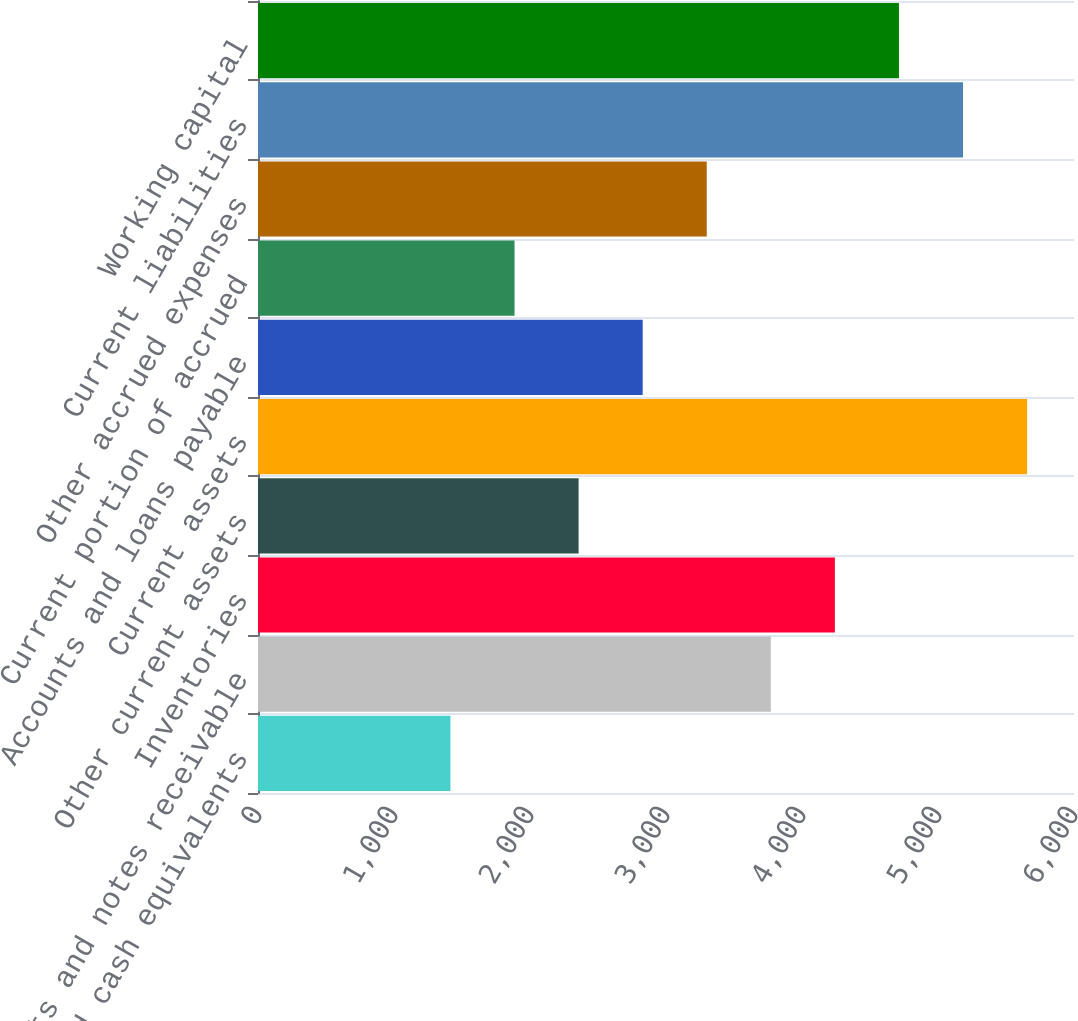Convert chart to OTSL. <chart><loc_0><loc_0><loc_500><loc_500><bar_chart><fcel>Cash and cash equivalents<fcel>Accounts and notes receivable<fcel>Inventories<fcel>Other current assets<fcel>Current assets<fcel>Accounts and loans payable<fcel>Current portion of accrued<fcel>Other accrued expenses<fcel>Current liabilities<fcel>Working capital<nl><fcel>1415.15<fcel>3770.75<fcel>4241.87<fcel>2357.39<fcel>5655.23<fcel>2828.51<fcel>1886.27<fcel>3299.63<fcel>5184.11<fcel>4712.99<nl></chart> 